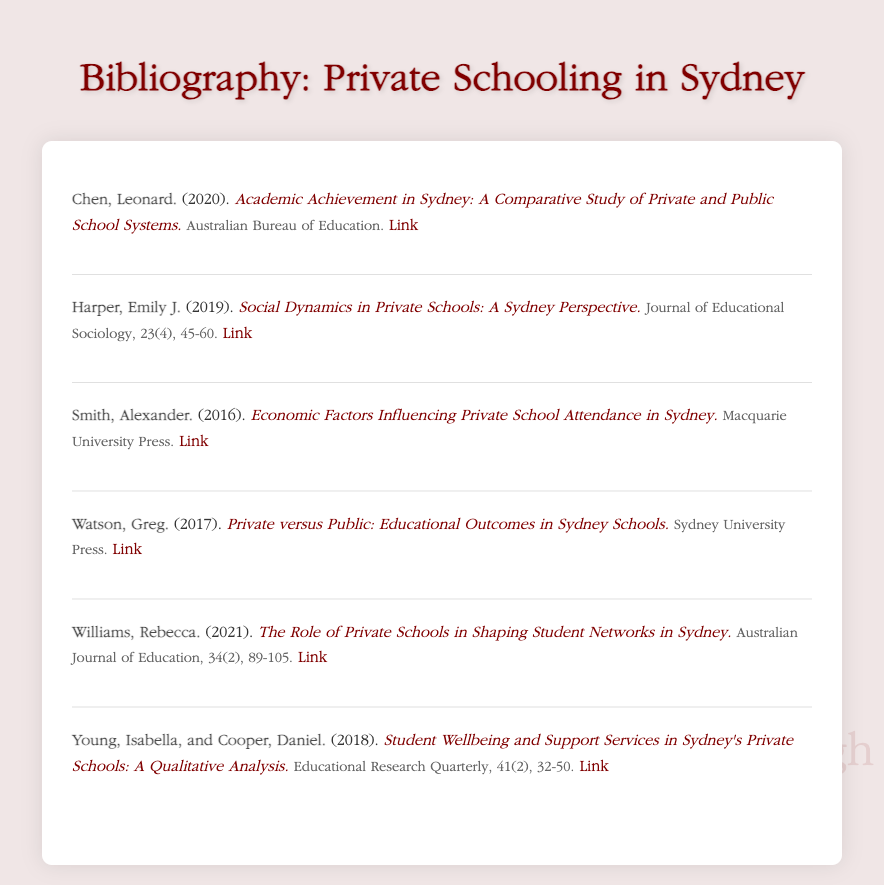what is the title of Leonard Chen's work? The title of Leonard Chen's work is found in the entry and is "Academic Achievement in Sydney: A Comparative Study of Private and Public School Systems."
Answer: Academic Achievement in Sydney: A Comparative Study of Private and Public School Systems who authored the paper on social dynamics in private schools? The author's name is mentioned in the entry specifically for the work about social dynamics, which is Emily J. Harper.
Answer: Emily J. Harper what year was the study on economic factors published? The publication year is indicated in the entry and is 2016.
Answer: 2016 which journal published Rebecca Williams' article? The journal title is included in the details of her entry; it is the "Australian Journal of Education."
Answer: Australian Journal of Education how many co-authors contributed to the study on student wellbeing and support services? The number of co-authors can be deduced from the entry, which mentions two: Isabella Young and Daniel Cooper.
Answer: 2 what is the main focus of Greg Watson's work? The main focus is indicated by the title in the entry, which compares educational outcomes between private and public schools.
Answer: Educational outcomes comparison which organization published the work by Leonard Chen? The publishing organization is listed in the entry for Chen's work, specifically the "Australian Bureau of Education."
Answer: Australian Bureau of Education what is the volume number of the journal that published the study by Young and Cooper? The volume number is part of the details in their entry, which states it is volume 41.
Answer: 41 which publication year is associated with the entry by Smith? The year is noted in the entry for Smith's work and is 2016.
Answer: 2016 